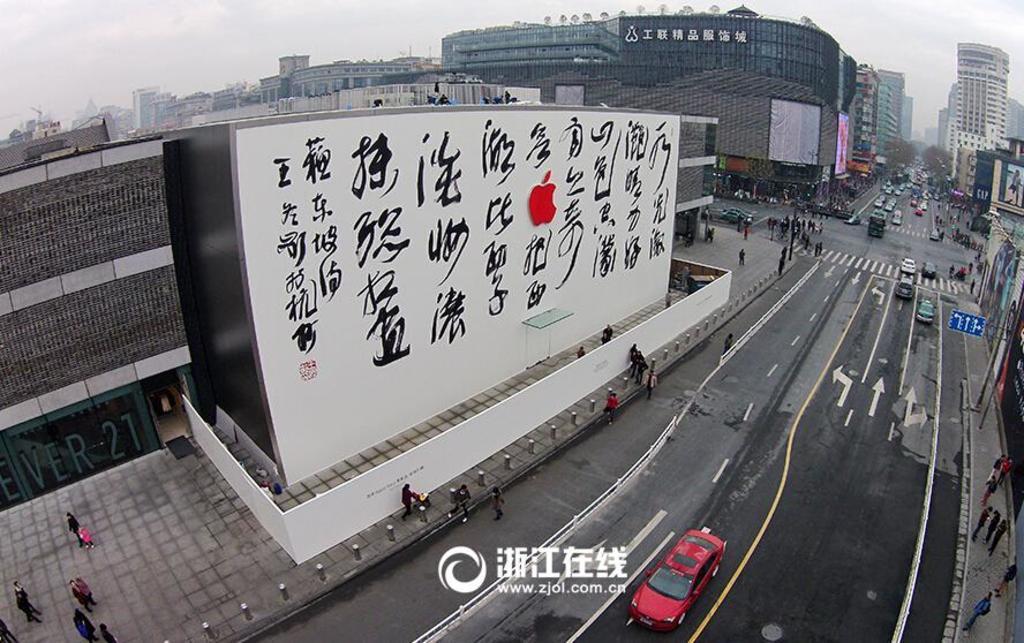Describe this image in one or two sentences. This is an outside view. On the right side, I can see some vehicles on the road and few people are walking on the footpath. In the background, I can see the buildings. On the top of the image I can see the sky. At the bottom of this image I can see some text. 